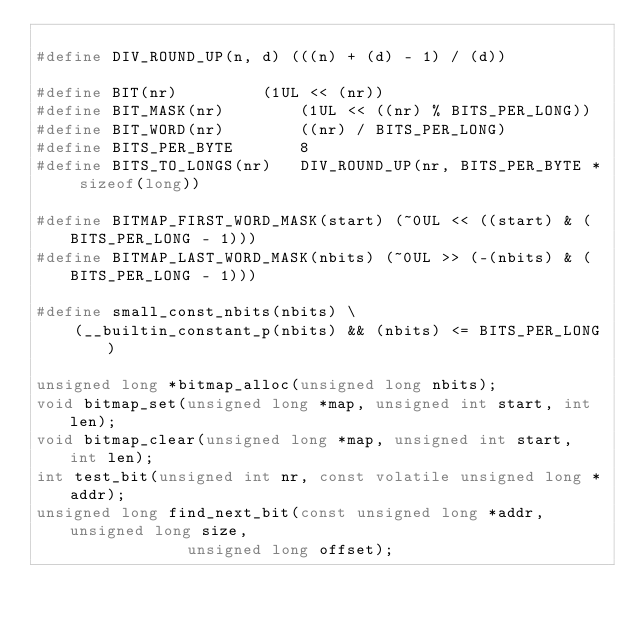<code> <loc_0><loc_0><loc_500><loc_500><_C_>
#define DIV_ROUND_UP(n, d) (((n) + (d) - 1) / (d))

#define BIT(nr)			(1UL << (nr))
#define BIT_MASK(nr)		(1UL << ((nr) % BITS_PER_LONG))
#define BIT_WORD(nr)		((nr) / BITS_PER_LONG)
#define BITS_PER_BYTE		8
#define BITS_TO_LONGS(nr)	DIV_ROUND_UP(nr, BITS_PER_BYTE * sizeof(long))

#define BITMAP_FIRST_WORD_MASK(start) (~0UL << ((start) & (BITS_PER_LONG - 1)))
#define BITMAP_LAST_WORD_MASK(nbits) (~0UL >> (-(nbits) & (BITS_PER_LONG - 1)))

#define small_const_nbits(nbits) \
	(__builtin_constant_p(nbits) && (nbits) <= BITS_PER_LONG)

unsigned long *bitmap_alloc(unsigned long nbits);
void bitmap_set(unsigned long *map, unsigned int start, int len);
void bitmap_clear(unsigned long *map, unsigned int start, int len);
int test_bit(unsigned int nr, const volatile unsigned long *addr);
unsigned long find_next_bit(const unsigned long *addr, unsigned long size,
			    unsigned long offset);</code> 